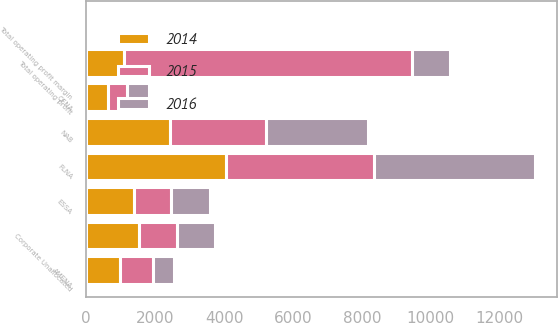<chart> <loc_0><loc_0><loc_500><loc_500><stacked_bar_chart><ecel><fcel>FLNA<fcel>QFNA<fcel>NAB<fcel>ESSA<fcel>AMENA<fcel>Corporate Unallocated<fcel>Total operating profit<fcel>Total operating profit margin<nl><fcel>2016<fcel>4659<fcel>653<fcel>2959<fcel>1108<fcel>619<fcel>1100<fcel>1104<fcel>15.6<nl><fcel>2015<fcel>4304<fcel>560<fcel>2785<fcel>1081<fcel>941<fcel>1112<fcel>8353<fcel>13.2<nl><fcel>2014<fcel>4054<fcel>621<fcel>2421<fcel>1389<fcel>985<fcel>1525<fcel>1104<fcel>14.4<nl></chart> 